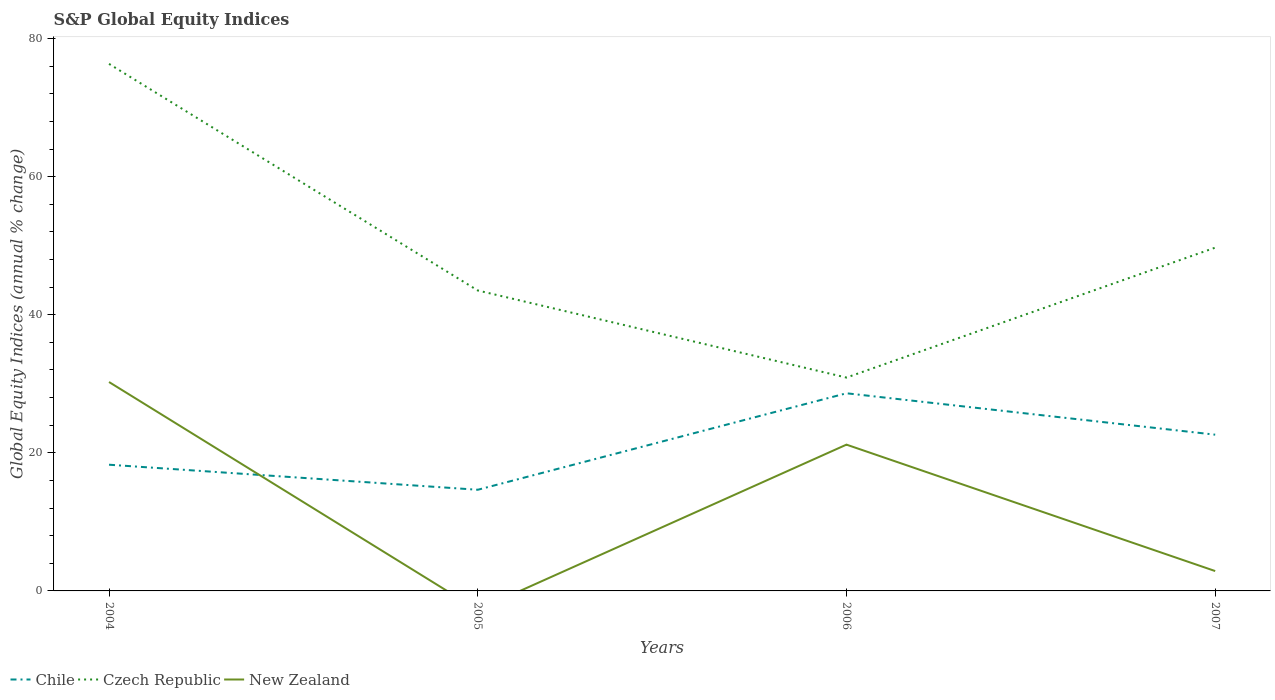How many different coloured lines are there?
Offer a terse response. 3. Across all years, what is the maximum global equity indices in Czech Republic?
Your answer should be very brief. 30.9. What is the total global equity indices in Chile in the graph?
Offer a very short reply. 3.63. What is the difference between the highest and the second highest global equity indices in Czech Republic?
Your response must be concise. 45.44. What is the difference between the highest and the lowest global equity indices in Chile?
Make the answer very short. 2. How many lines are there?
Give a very brief answer. 3. How many years are there in the graph?
Offer a terse response. 4. What is the difference between two consecutive major ticks on the Y-axis?
Ensure brevity in your answer.  20. Does the graph contain any zero values?
Offer a terse response. Yes. Does the graph contain grids?
Ensure brevity in your answer.  No. Where does the legend appear in the graph?
Your response must be concise. Bottom left. How many legend labels are there?
Ensure brevity in your answer.  3. How are the legend labels stacked?
Give a very brief answer. Horizontal. What is the title of the graph?
Ensure brevity in your answer.  S&P Global Equity Indices. Does "Slovenia" appear as one of the legend labels in the graph?
Keep it short and to the point. No. What is the label or title of the Y-axis?
Give a very brief answer. Global Equity Indices (annual % change). What is the Global Equity Indices (annual % change) in Chile in 2004?
Ensure brevity in your answer.  18.28. What is the Global Equity Indices (annual % change) in Czech Republic in 2004?
Provide a short and direct response. 76.34. What is the Global Equity Indices (annual % change) of New Zealand in 2004?
Offer a terse response. 30.26. What is the Global Equity Indices (annual % change) of Chile in 2005?
Offer a terse response. 14.65. What is the Global Equity Indices (annual % change) in Czech Republic in 2005?
Provide a short and direct response. 43.52. What is the Global Equity Indices (annual % change) of Chile in 2006?
Provide a succinct answer. 28.63. What is the Global Equity Indices (annual % change) of Czech Republic in 2006?
Offer a very short reply. 30.9. What is the Global Equity Indices (annual % change) of New Zealand in 2006?
Your answer should be compact. 21.19. What is the Global Equity Indices (annual % change) in Chile in 2007?
Provide a short and direct response. 22.63. What is the Global Equity Indices (annual % change) in Czech Republic in 2007?
Your response must be concise. 49.72. What is the Global Equity Indices (annual % change) of New Zealand in 2007?
Provide a succinct answer. 2.88. Across all years, what is the maximum Global Equity Indices (annual % change) of Chile?
Offer a very short reply. 28.63. Across all years, what is the maximum Global Equity Indices (annual % change) of Czech Republic?
Ensure brevity in your answer.  76.34. Across all years, what is the maximum Global Equity Indices (annual % change) of New Zealand?
Offer a terse response. 30.26. Across all years, what is the minimum Global Equity Indices (annual % change) in Chile?
Your answer should be compact. 14.65. Across all years, what is the minimum Global Equity Indices (annual % change) of Czech Republic?
Offer a terse response. 30.9. What is the total Global Equity Indices (annual % change) of Chile in the graph?
Give a very brief answer. 84.19. What is the total Global Equity Indices (annual % change) in Czech Republic in the graph?
Provide a short and direct response. 200.48. What is the total Global Equity Indices (annual % change) in New Zealand in the graph?
Keep it short and to the point. 54.33. What is the difference between the Global Equity Indices (annual % change) in Chile in 2004 and that in 2005?
Ensure brevity in your answer.  3.63. What is the difference between the Global Equity Indices (annual % change) in Czech Republic in 2004 and that in 2005?
Provide a short and direct response. 32.82. What is the difference between the Global Equity Indices (annual % change) in Chile in 2004 and that in 2006?
Provide a succinct answer. -10.35. What is the difference between the Global Equity Indices (annual % change) of Czech Republic in 2004 and that in 2006?
Give a very brief answer. 45.44. What is the difference between the Global Equity Indices (annual % change) in New Zealand in 2004 and that in 2006?
Provide a succinct answer. 9.07. What is the difference between the Global Equity Indices (annual % change) of Chile in 2004 and that in 2007?
Your answer should be compact. -4.35. What is the difference between the Global Equity Indices (annual % change) in Czech Republic in 2004 and that in 2007?
Give a very brief answer. 26.62. What is the difference between the Global Equity Indices (annual % change) in New Zealand in 2004 and that in 2007?
Your answer should be very brief. 27.38. What is the difference between the Global Equity Indices (annual % change) in Chile in 2005 and that in 2006?
Offer a terse response. -13.98. What is the difference between the Global Equity Indices (annual % change) of Czech Republic in 2005 and that in 2006?
Your response must be concise. 12.62. What is the difference between the Global Equity Indices (annual % change) in Chile in 2005 and that in 2007?
Your answer should be compact. -7.98. What is the difference between the Global Equity Indices (annual % change) of Czech Republic in 2005 and that in 2007?
Your answer should be very brief. -6.2. What is the difference between the Global Equity Indices (annual % change) of Chile in 2006 and that in 2007?
Your answer should be very brief. 6. What is the difference between the Global Equity Indices (annual % change) of Czech Republic in 2006 and that in 2007?
Provide a short and direct response. -18.82. What is the difference between the Global Equity Indices (annual % change) of New Zealand in 2006 and that in 2007?
Your answer should be compact. 18.31. What is the difference between the Global Equity Indices (annual % change) in Chile in 2004 and the Global Equity Indices (annual % change) in Czech Republic in 2005?
Offer a very short reply. -25.24. What is the difference between the Global Equity Indices (annual % change) in Chile in 2004 and the Global Equity Indices (annual % change) in Czech Republic in 2006?
Provide a succinct answer. -12.62. What is the difference between the Global Equity Indices (annual % change) in Chile in 2004 and the Global Equity Indices (annual % change) in New Zealand in 2006?
Give a very brief answer. -2.91. What is the difference between the Global Equity Indices (annual % change) in Czech Republic in 2004 and the Global Equity Indices (annual % change) in New Zealand in 2006?
Your answer should be very brief. 55.15. What is the difference between the Global Equity Indices (annual % change) of Chile in 2004 and the Global Equity Indices (annual % change) of Czech Republic in 2007?
Offer a terse response. -31.44. What is the difference between the Global Equity Indices (annual % change) in Chile in 2004 and the Global Equity Indices (annual % change) in New Zealand in 2007?
Make the answer very short. 15.4. What is the difference between the Global Equity Indices (annual % change) in Czech Republic in 2004 and the Global Equity Indices (annual % change) in New Zealand in 2007?
Your answer should be compact. 73.46. What is the difference between the Global Equity Indices (annual % change) of Chile in 2005 and the Global Equity Indices (annual % change) of Czech Republic in 2006?
Your response must be concise. -16.25. What is the difference between the Global Equity Indices (annual % change) of Chile in 2005 and the Global Equity Indices (annual % change) of New Zealand in 2006?
Keep it short and to the point. -6.54. What is the difference between the Global Equity Indices (annual % change) of Czech Republic in 2005 and the Global Equity Indices (annual % change) of New Zealand in 2006?
Provide a short and direct response. 22.33. What is the difference between the Global Equity Indices (annual % change) in Chile in 2005 and the Global Equity Indices (annual % change) in Czech Republic in 2007?
Your answer should be compact. -35.07. What is the difference between the Global Equity Indices (annual % change) of Chile in 2005 and the Global Equity Indices (annual % change) of New Zealand in 2007?
Make the answer very short. 11.77. What is the difference between the Global Equity Indices (annual % change) in Czech Republic in 2005 and the Global Equity Indices (annual % change) in New Zealand in 2007?
Ensure brevity in your answer.  40.64. What is the difference between the Global Equity Indices (annual % change) of Chile in 2006 and the Global Equity Indices (annual % change) of Czech Republic in 2007?
Provide a succinct answer. -21.09. What is the difference between the Global Equity Indices (annual % change) in Chile in 2006 and the Global Equity Indices (annual % change) in New Zealand in 2007?
Your answer should be very brief. 25.75. What is the difference between the Global Equity Indices (annual % change) of Czech Republic in 2006 and the Global Equity Indices (annual % change) of New Zealand in 2007?
Ensure brevity in your answer.  28.02. What is the average Global Equity Indices (annual % change) in Chile per year?
Make the answer very short. 21.05. What is the average Global Equity Indices (annual % change) in Czech Republic per year?
Give a very brief answer. 50.12. What is the average Global Equity Indices (annual % change) of New Zealand per year?
Provide a short and direct response. 13.58. In the year 2004, what is the difference between the Global Equity Indices (annual % change) of Chile and Global Equity Indices (annual % change) of Czech Republic?
Offer a very short reply. -58.06. In the year 2004, what is the difference between the Global Equity Indices (annual % change) of Chile and Global Equity Indices (annual % change) of New Zealand?
Keep it short and to the point. -11.98. In the year 2004, what is the difference between the Global Equity Indices (annual % change) in Czech Republic and Global Equity Indices (annual % change) in New Zealand?
Keep it short and to the point. 46.08. In the year 2005, what is the difference between the Global Equity Indices (annual % change) in Chile and Global Equity Indices (annual % change) in Czech Republic?
Provide a short and direct response. -28.87. In the year 2006, what is the difference between the Global Equity Indices (annual % change) of Chile and Global Equity Indices (annual % change) of Czech Republic?
Provide a succinct answer. -2.27. In the year 2006, what is the difference between the Global Equity Indices (annual % change) of Chile and Global Equity Indices (annual % change) of New Zealand?
Provide a short and direct response. 7.44. In the year 2006, what is the difference between the Global Equity Indices (annual % change) in Czech Republic and Global Equity Indices (annual % change) in New Zealand?
Provide a succinct answer. 9.71. In the year 2007, what is the difference between the Global Equity Indices (annual % change) in Chile and Global Equity Indices (annual % change) in Czech Republic?
Your answer should be compact. -27.09. In the year 2007, what is the difference between the Global Equity Indices (annual % change) in Chile and Global Equity Indices (annual % change) in New Zealand?
Your answer should be very brief. 19.75. In the year 2007, what is the difference between the Global Equity Indices (annual % change) of Czech Republic and Global Equity Indices (annual % change) of New Zealand?
Your answer should be very brief. 46.84. What is the ratio of the Global Equity Indices (annual % change) in Chile in 2004 to that in 2005?
Provide a short and direct response. 1.25. What is the ratio of the Global Equity Indices (annual % change) in Czech Republic in 2004 to that in 2005?
Offer a terse response. 1.75. What is the ratio of the Global Equity Indices (annual % change) in Chile in 2004 to that in 2006?
Keep it short and to the point. 0.64. What is the ratio of the Global Equity Indices (annual % change) of Czech Republic in 2004 to that in 2006?
Provide a short and direct response. 2.47. What is the ratio of the Global Equity Indices (annual % change) of New Zealand in 2004 to that in 2006?
Keep it short and to the point. 1.43. What is the ratio of the Global Equity Indices (annual % change) of Chile in 2004 to that in 2007?
Offer a terse response. 0.81. What is the ratio of the Global Equity Indices (annual % change) of Czech Republic in 2004 to that in 2007?
Your response must be concise. 1.54. What is the ratio of the Global Equity Indices (annual % change) in New Zealand in 2004 to that in 2007?
Your answer should be very brief. 10.51. What is the ratio of the Global Equity Indices (annual % change) in Chile in 2005 to that in 2006?
Give a very brief answer. 0.51. What is the ratio of the Global Equity Indices (annual % change) in Czech Republic in 2005 to that in 2006?
Offer a very short reply. 1.41. What is the ratio of the Global Equity Indices (annual % change) of Chile in 2005 to that in 2007?
Provide a succinct answer. 0.65. What is the ratio of the Global Equity Indices (annual % change) in Czech Republic in 2005 to that in 2007?
Your answer should be very brief. 0.88. What is the ratio of the Global Equity Indices (annual % change) in Chile in 2006 to that in 2007?
Your answer should be compact. 1.26. What is the ratio of the Global Equity Indices (annual % change) in Czech Republic in 2006 to that in 2007?
Ensure brevity in your answer.  0.62. What is the ratio of the Global Equity Indices (annual % change) of New Zealand in 2006 to that in 2007?
Give a very brief answer. 7.36. What is the difference between the highest and the second highest Global Equity Indices (annual % change) in Chile?
Ensure brevity in your answer.  6. What is the difference between the highest and the second highest Global Equity Indices (annual % change) in Czech Republic?
Make the answer very short. 26.62. What is the difference between the highest and the second highest Global Equity Indices (annual % change) of New Zealand?
Make the answer very short. 9.07. What is the difference between the highest and the lowest Global Equity Indices (annual % change) in Chile?
Keep it short and to the point. 13.98. What is the difference between the highest and the lowest Global Equity Indices (annual % change) in Czech Republic?
Keep it short and to the point. 45.44. What is the difference between the highest and the lowest Global Equity Indices (annual % change) in New Zealand?
Make the answer very short. 30.26. 